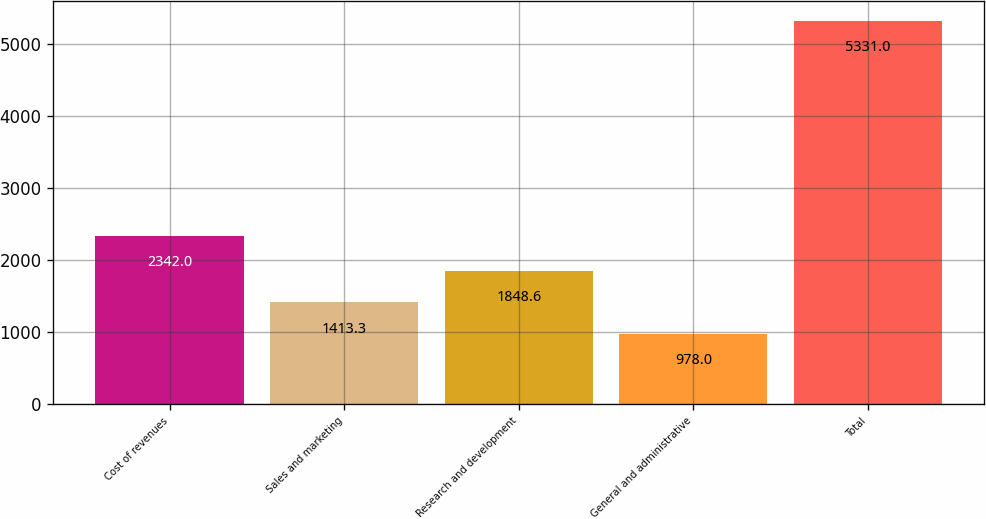Convert chart to OTSL. <chart><loc_0><loc_0><loc_500><loc_500><bar_chart><fcel>Cost of revenues<fcel>Sales and marketing<fcel>Research and development<fcel>General and administrative<fcel>Total<nl><fcel>2342<fcel>1413.3<fcel>1848.6<fcel>978<fcel>5331<nl></chart> 